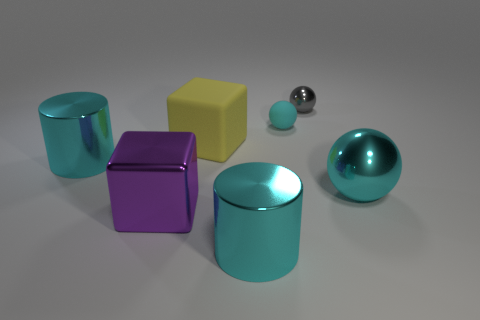Add 2 cyan metal things. How many objects exist? 9 Subtract all balls. How many objects are left? 4 Add 4 cyan things. How many cyan things are left? 8 Add 6 cyan cylinders. How many cyan cylinders exist? 8 Subtract 0 red spheres. How many objects are left? 7 Subtract all large cyan spheres. Subtract all cyan matte objects. How many objects are left? 5 